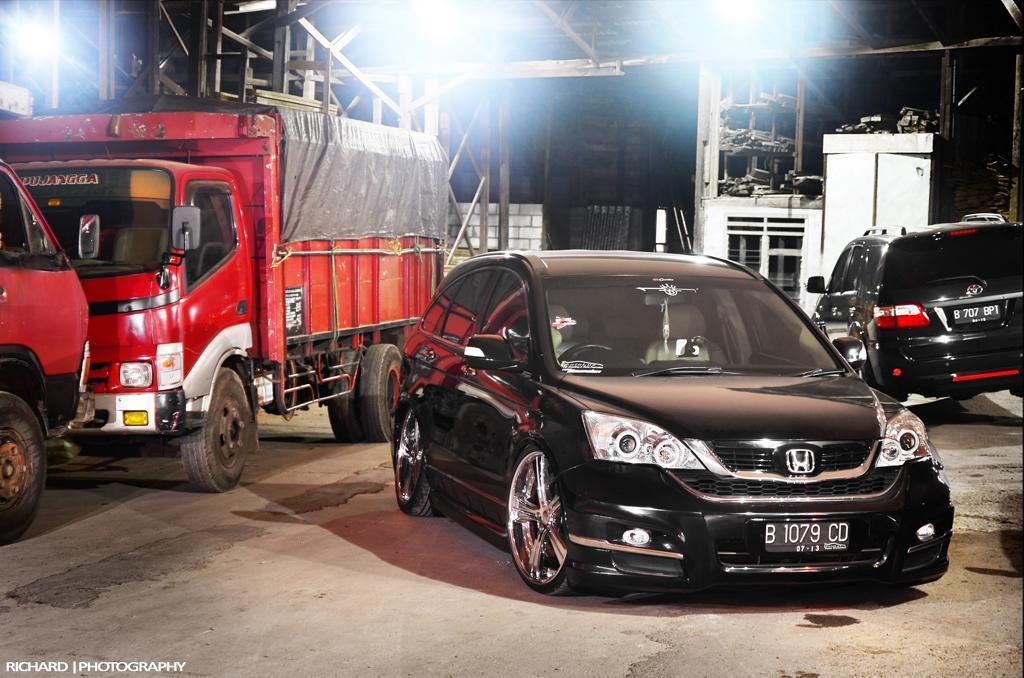Can you describe this image briefly? In the center of the image we can see some vehicles. In the background of the image we can see wall, transformer, rods. At the bottom of the image we can see road and some text. 